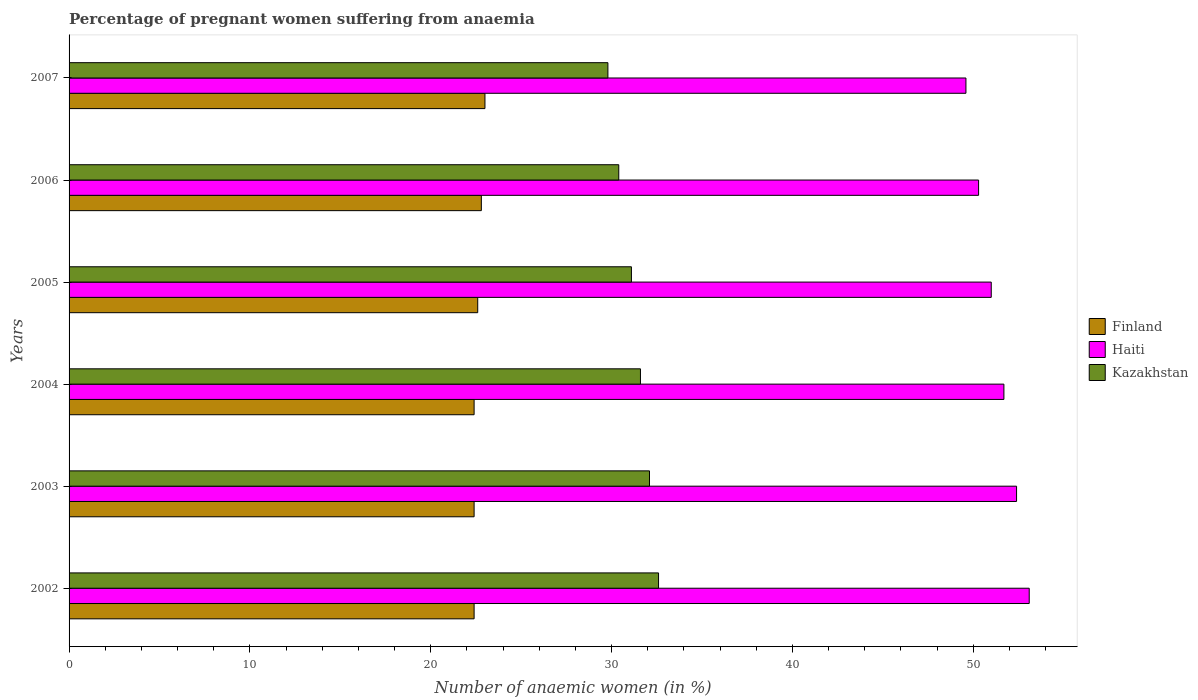How many groups of bars are there?
Offer a very short reply. 6. Are the number of bars per tick equal to the number of legend labels?
Provide a short and direct response. Yes. How many bars are there on the 5th tick from the top?
Offer a terse response. 3. In how many cases, is the number of bars for a given year not equal to the number of legend labels?
Your answer should be very brief. 0. What is the number of anaemic women in Haiti in 2004?
Keep it short and to the point. 51.7. Across all years, what is the maximum number of anaemic women in Haiti?
Your answer should be compact. 53.1. Across all years, what is the minimum number of anaemic women in Kazakhstan?
Your response must be concise. 29.8. In which year was the number of anaemic women in Kazakhstan minimum?
Give a very brief answer. 2007. What is the total number of anaemic women in Haiti in the graph?
Provide a short and direct response. 308.1. What is the difference between the number of anaemic women in Haiti in 2004 and that in 2006?
Make the answer very short. 1.4. What is the difference between the number of anaemic women in Finland in 2006 and the number of anaemic women in Kazakhstan in 2005?
Give a very brief answer. -8.3. What is the average number of anaemic women in Finland per year?
Provide a succinct answer. 22.6. In the year 2006, what is the difference between the number of anaemic women in Finland and number of anaemic women in Haiti?
Your response must be concise. -27.5. What is the ratio of the number of anaemic women in Kazakhstan in 2003 to that in 2007?
Offer a terse response. 1.08. What is the difference between the highest and the second highest number of anaemic women in Haiti?
Provide a succinct answer. 0.7. What is the difference between the highest and the lowest number of anaemic women in Kazakhstan?
Make the answer very short. 2.8. What does the 2nd bar from the top in 2002 represents?
Offer a terse response. Haiti. What does the 3rd bar from the bottom in 2007 represents?
Make the answer very short. Kazakhstan. Is it the case that in every year, the sum of the number of anaemic women in Kazakhstan and number of anaemic women in Haiti is greater than the number of anaemic women in Finland?
Keep it short and to the point. Yes. How many bars are there?
Ensure brevity in your answer.  18. Are the values on the major ticks of X-axis written in scientific E-notation?
Keep it short and to the point. No. Does the graph contain any zero values?
Your response must be concise. No. What is the title of the graph?
Your response must be concise. Percentage of pregnant women suffering from anaemia. Does "San Marino" appear as one of the legend labels in the graph?
Offer a very short reply. No. What is the label or title of the X-axis?
Your answer should be compact. Number of anaemic women (in %). What is the Number of anaemic women (in %) of Finland in 2002?
Make the answer very short. 22.4. What is the Number of anaemic women (in %) of Haiti in 2002?
Your answer should be compact. 53.1. What is the Number of anaemic women (in %) in Kazakhstan in 2002?
Provide a short and direct response. 32.6. What is the Number of anaemic women (in %) in Finland in 2003?
Your answer should be compact. 22.4. What is the Number of anaemic women (in %) in Haiti in 2003?
Your answer should be very brief. 52.4. What is the Number of anaemic women (in %) of Kazakhstan in 2003?
Provide a succinct answer. 32.1. What is the Number of anaemic women (in %) in Finland in 2004?
Ensure brevity in your answer.  22.4. What is the Number of anaemic women (in %) of Haiti in 2004?
Your response must be concise. 51.7. What is the Number of anaemic women (in %) in Kazakhstan in 2004?
Offer a very short reply. 31.6. What is the Number of anaemic women (in %) in Finland in 2005?
Provide a succinct answer. 22.6. What is the Number of anaemic women (in %) of Haiti in 2005?
Provide a short and direct response. 51. What is the Number of anaemic women (in %) in Kazakhstan in 2005?
Your response must be concise. 31.1. What is the Number of anaemic women (in %) of Finland in 2006?
Offer a very short reply. 22.8. What is the Number of anaemic women (in %) of Haiti in 2006?
Make the answer very short. 50.3. What is the Number of anaemic women (in %) of Kazakhstan in 2006?
Your answer should be very brief. 30.4. What is the Number of anaemic women (in %) of Haiti in 2007?
Provide a short and direct response. 49.6. What is the Number of anaemic women (in %) in Kazakhstan in 2007?
Your response must be concise. 29.8. Across all years, what is the maximum Number of anaemic women (in %) in Haiti?
Your answer should be compact. 53.1. Across all years, what is the maximum Number of anaemic women (in %) in Kazakhstan?
Your answer should be very brief. 32.6. Across all years, what is the minimum Number of anaemic women (in %) of Finland?
Provide a short and direct response. 22.4. Across all years, what is the minimum Number of anaemic women (in %) in Haiti?
Provide a short and direct response. 49.6. Across all years, what is the minimum Number of anaemic women (in %) in Kazakhstan?
Provide a short and direct response. 29.8. What is the total Number of anaemic women (in %) of Finland in the graph?
Offer a terse response. 135.6. What is the total Number of anaemic women (in %) in Haiti in the graph?
Your answer should be very brief. 308.1. What is the total Number of anaemic women (in %) in Kazakhstan in the graph?
Provide a succinct answer. 187.6. What is the difference between the Number of anaemic women (in %) of Kazakhstan in 2002 and that in 2003?
Offer a very short reply. 0.5. What is the difference between the Number of anaemic women (in %) of Kazakhstan in 2002 and that in 2004?
Provide a succinct answer. 1. What is the difference between the Number of anaemic women (in %) of Haiti in 2002 and that in 2005?
Keep it short and to the point. 2.1. What is the difference between the Number of anaemic women (in %) in Haiti in 2002 and that in 2006?
Your response must be concise. 2.8. What is the difference between the Number of anaemic women (in %) of Finland in 2002 and that in 2007?
Offer a very short reply. -0.6. What is the difference between the Number of anaemic women (in %) of Kazakhstan in 2002 and that in 2007?
Keep it short and to the point. 2.8. What is the difference between the Number of anaemic women (in %) of Finland in 2003 and that in 2004?
Keep it short and to the point. 0. What is the difference between the Number of anaemic women (in %) of Haiti in 2003 and that in 2004?
Offer a terse response. 0.7. What is the difference between the Number of anaemic women (in %) of Kazakhstan in 2003 and that in 2004?
Ensure brevity in your answer.  0.5. What is the difference between the Number of anaemic women (in %) in Finland in 2003 and that in 2005?
Offer a very short reply. -0.2. What is the difference between the Number of anaemic women (in %) of Haiti in 2003 and that in 2005?
Keep it short and to the point. 1.4. What is the difference between the Number of anaemic women (in %) in Kazakhstan in 2003 and that in 2005?
Your answer should be very brief. 1. What is the difference between the Number of anaemic women (in %) of Haiti in 2003 and that in 2006?
Your answer should be very brief. 2.1. What is the difference between the Number of anaemic women (in %) in Haiti in 2003 and that in 2007?
Make the answer very short. 2.8. What is the difference between the Number of anaemic women (in %) in Kazakhstan in 2003 and that in 2007?
Give a very brief answer. 2.3. What is the difference between the Number of anaemic women (in %) in Haiti in 2004 and that in 2005?
Make the answer very short. 0.7. What is the difference between the Number of anaemic women (in %) of Kazakhstan in 2004 and that in 2006?
Provide a succinct answer. 1.2. What is the difference between the Number of anaemic women (in %) of Finland in 2004 and that in 2007?
Provide a succinct answer. -0.6. What is the difference between the Number of anaemic women (in %) of Haiti in 2004 and that in 2007?
Make the answer very short. 2.1. What is the difference between the Number of anaemic women (in %) in Finland in 2005 and that in 2006?
Provide a short and direct response. -0.2. What is the difference between the Number of anaemic women (in %) of Haiti in 2005 and that in 2006?
Your answer should be compact. 0.7. What is the difference between the Number of anaemic women (in %) in Finland in 2005 and that in 2007?
Offer a very short reply. -0.4. What is the difference between the Number of anaemic women (in %) of Haiti in 2005 and that in 2007?
Your answer should be very brief. 1.4. What is the difference between the Number of anaemic women (in %) in Kazakhstan in 2005 and that in 2007?
Provide a short and direct response. 1.3. What is the difference between the Number of anaemic women (in %) of Kazakhstan in 2006 and that in 2007?
Keep it short and to the point. 0.6. What is the difference between the Number of anaemic women (in %) in Finland in 2002 and the Number of anaemic women (in %) in Haiti in 2004?
Your response must be concise. -29.3. What is the difference between the Number of anaemic women (in %) in Haiti in 2002 and the Number of anaemic women (in %) in Kazakhstan in 2004?
Keep it short and to the point. 21.5. What is the difference between the Number of anaemic women (in %) in Finland in 2002 and the Number of anaemic women (in %) in Haiti in 2005?
Make the answer very short. -28.6. What is the difference between the Number of anaemic women (in %) in Haiti in 2002 and the Number of anaemic women (in %) in Kazakhstan in 2005?
Offer a terse response. 22. What is the difference between the Number of anaemic women (in %) of Finland in 2002 and the Number of anaemic women (in %) of Haiti in 2006?
Your answer should be very brief. -27.9. What is the difference between the Number of anaemic women (in %) in Finland in 2002 and the Number of anaemic women (in %) in Kazakhstan in 2006?
Make the answer very short. -8. What is the difference between the Number of anaemic women (in %) in Haiti in 2002 and the Number of anaemic women (in %) in Kazakhstan in 2006?
Make the answer very short. 22.7. What is the difference between the Number of anaemic women (in %) in Finland in 2002 and the Number of anaemic women (in %) in Haiti in 2007?
Give a very brief answer. -27.2. What is the difference between the Number of anaemic women (in %) in Finland in 2002 and the Number of anaemic women (in %) in Kazakhstan in 2007?
Your response must be concise. -7.4. What is the difference between the Number of anaemic women (in %) in Haiti in 2002 and the Number of anaemic women (in %) in Kazakhstan in 2007?
Keep it short and to the point. 23.3. What is the difference between the Number of anaemic women (in %) of Finland in 2003 and the Number of anaemic women (in %) of Haiti in 2004?
Your answer should be compact. -29.3. What is the difference between the Number of anaemic women (in %) in Haiti in 2003 and the Number of anaemic women (in %) in Kazakhstan in 2004?
Keep it short and to the point. 20.8. What is the difference between the Number of anaemic women (in %) in Finland in 2003 and the Number of anaemic women (in %) in Haiti in 2005?
Offer a terse response. -28.6. What is the difference between the Number of anaemic women (in %) of Haiti in 2003 and the Number of anaemic women (in %) of Kazakhstan in 2005?
Provide a short and direct response. 21.3. What is the difference between the Number of anaemic women (in %) of Finland in 2003 and the Number of anaemic women (in %) of Haiti in 2006?
Give a very brief answer. -27.9. What is the difference between the Number of anaemic women (in %) in Finland in 2003 and the Number of anaemic women (in %) in Haiti in 2007?
Keep it short and to the point. -27.2. What is the difference between the Number of anaemic women (in %) of Finland in 2003 and the Number of anaemic women (in %) of Kazakhstan in 2007?
Your answer should be compact. -7.4. What is the difference between the Number of anaemic women (in %) of Haiti in 2003 and the Number of anaemic women (in %) of Kazakhstan in 2007?
Provide a short and direct response. 22.6. What is the difference between the Number of anaemic women (in %) in Finland in 2004 and the Number of anaemic women (in %) in Haiti in 2005?
Make the answer very short. -28.6. What is the difference between the Number of anaemic women (in %) in Haiti in 2004 and the Number of anaemic women (in %) in Kazakhstan in 2005?
Your response must be concise. 20.6. What is the difference between the Number of anaemic women (in %) of Finland in 2004 and the Number of anaemic women (in %) of Haiti in 2006?
Your answer should be compact. -27.9. What is the difference between the Number of anaemic women (in %) of Finland in 2004 and the Number of anaemic women (in %) of Kazakhstan in 2006?
Offer a terse response. -8. What is the difference between the Number of anaemic women (in %) of Haiti in 2004 and the Number of anaemic women (in %) of Kazakhstan in 2006?
Keep it short and to the point. 21.3. What is the difference between the Number of anaemic women (in %) of Finland in 2004 and the Number of anaemic women (in %) of Haiti in 2007?
Your response must be concise. -27.2. What is the difference between the Number of anaemic women (in %) of Haiti in 2004 and the Number of anaemic women (in %) of Kazakhstan in 2007?
Your answer should be compact. 21.9. What is the difference between the Number of anaemic women (in %) in Finland in 2005 and the Number of anaemic women (in %) in Haiti in 2006?
Ensure brevity in your answer.  -27.7. What is the difference between the Number of anaemic women (in %) of Finland in 2005 and the Number of anaemic women (in %) of Kazakhstan in 2006?
Give a very brief answer. -7.8. What is the difference between the Number of anaemic women (in %) of Haiti in 2005 and the Number of anaemic women (in %) of Kazakhstan in 2006?
Provide a succinct answer. 20.6. What is the difference between the Number of anaemic women (in %) in Haiti in 2005 and the Number of anaemic women (in %) in Kazakhstan in 2007?
Your answer should be compact. 21.2. What is the difference between the Number of anaemic women (in %) in Finland in 2006 and the Number of anaemic women (in %) in Haiti in 2007?
Provide a short and direct response. -26.8. What is the average Number of anaemic women (in %) in Finland per year?
Provide a short and direct response. 22.6. What is the average Number of anaemic women (in %) in Haiti per year?
Your answer should be very brief. 51.35. What is the average Number of anaemic women (in %) in Kazakhstan per year?
Provide a short and direct response. 31.27. In the year 2002, what is the difference between the Number of anaemic women (in %) in Finland and Number of anaemic women (in %) in Haiti?
Your answer should be very brief. -30.7. In the year 2003, what is the difference between the Number of anaemic women (in %) of Finland and Number of anaemic women (in %) of Haiti?
Give a very brief answer. -30. In the year 2003, what is the difference between the Number of anaemic women (in %) of Finland and Number of anaemic women (in %) of Kazakhstan?
Your answer should be compact. -9.7. In the year 2003, what is the difference between the Number of anaemic women (in %) of Haiti and Number of anaemic women (in %) of Kazakhstan?
Give a very brief answer. 20.3. In the year 2004, what is the difference between the Number of anaemic women (in %) in Finland and Number of anaemic women (in %) in Haiti?
Provide a succinct answer. -29.3. In the year 2004, what is the difference between the Number of anaemic women (in %) of Finland and Number of anaemic women (in %) of Kazakhstan?
Make the answer very short. -9.2. In the year 2004, what is the difference between the Number of anaemic women (in %) of Haiti and Number of anaemic women (in %) of Kazakhstan?
Provide a short and direct response. 20.1. In the year 2005, what is the difference between the Number of anaemic women (in %) in Finland and Number of anaemic women (in %) in Haiti?
Make the answer very short. -28.4. In the year 2006, what is the difference between the Number of anaemic women (in %) in Finland and Number of anaemic women (in %) in Haiti?
Give a very brief answer. -27.5. In the year 2006, what is the difference between the Number of anaemic women (in %) in Finland and Number of anaemic women (in %) in Kazakhstan?
Offer a very short reply. -7.6. In the year 2007, what is the difference between the Number of anaemic women (in %) of Finland and Number of anaemic women (in %) of Haiti?
Provide a succinct answer. -26.6. In the year 2007, what is the difference between the Number of anaemic women (in %) of Finland and Number of anaemic women (in %) of Kazakhstan?
Provide a succinct answer. -6.8. In the year 2007, what is the difference between the Number of anaemic women (in %) of Haiti and Number of anaemic women (in %) of Kazakhstan?
Offer a terse response. 19.8. What is the ratio of the Number of anaemic women (in %) of Haiti in 2002 to that in 2003?
Give a very brief answer. 1.01. What is the ratio of the Number of anaemic women (in %) in Kazakhstan in 2002 to that in 2003?
Offer a terse response. 1.02. What is the ratio of the Number of anaemic women (in %) of Finland in 2002 to that in 2004?
Provide a succinct answer. 1. What is the ratio of the Number of anaemic women (in %) of Haiti in 2002 to that in 2004?
Your answer should be very brief. 1.03. What is the ratio of the Number of anaemic women (in %) in Kazakhstan in 2002 to that in 2004?
Your response must be concise. 1.03. What is the ratio of the Number of anaemic women (in %) of Finland in 2002 to that in 2005?
Provide a succinct answer. 0.99. What is the ratio of the Number of anaemic women (in %) of Haiti in 2002 to that in 2005?
Make the answer very short. 1.04. What is the ratio of the Number of anaemic women (in %) of Kazakhstan in 2002 to that in 2005?
Your response must be concise. 1.05. What is the ratio of the Number of anaemic women (in %) of Finland in 2002 to that in 2006?
Make the answer very short. 0.98. What is the ratio of the Number of anaemic women (in %) in Haiti in 2002 to that in 2006?
Offer a terse response. 1.06. What is the ratio of the Number of anaemic women (in %) in Kazakhstan in 2002 to that in 2006?
Your answer should be compact. 1.07. What is the ratio of the Number of anaemic women (in %) in Finland in 2002 to that in 2007?
Offer a very short reply. 0.97. What is the ratio of the Number of anaemic women (in %) of Haiti in 2002 to that in 2007?
Your answer should be very brief. 1.07. What is the ratio of the Number of anaemic women (in %) of Kazakhstan in 2002 to that in 2007?
Give a very brief answer. 1.09. What is the ratio of the Number of anaemic women (in %) of Finland in 2003 to that in 2004?
Offer a terse response. 1. What is the ratio of the Number of anaemic women (in %) of Haiti in 2003 to that in 2004?
Give a very brief answer. 1.01. What is the ratio of the Number of anaemic women (in %) of Kazakhstan in 2003 to that in 2004?
Provide a short and direct response. 1.02. What is the ratio of the Number of anaemic women (in %) in Haiti in 2003 to that in 2005?
Make the answer very short. 1.03. What is the ratio of the Number of anaemic women (in %) in Kazakhstan in 2003 to that in 2005?
Offer a terse response. 1.03. What is the ratio of the Number of anaemic women (in %) of Finland in 2003 to that in 2006?
Make the answer very short. 0.98. What is the ratio of the Number of anaemic women (in %) in Haiti in 2003 to that in 2006?
Offer a terse response. 1.04. What is the ratio of the Number of anaemic women (in %) in Kazakhstan in 2003 to that in 2006?
Offer a very short reply. 1.06. What is the ratio of the Number of anaemic women (in %) of Finland in 2003 to that in 2007?
Ensure brevity in your answer.  0.97. What is the ratio of the Number of anaemic women (in %) in Haiti in 2003 to that in 2007?
Offer a terse response. 1.06. What is the ratio of the Number of anaemic women (in %) in Kazakhstan in 2003 to that in 2007?
Your response must be concise. 1.08. What is the ratio of the Number of anaemic women (in %) in Finland in 2004 to that in 2005?
Offer a terse response. 0.99. What is the ratio of the Number of anaemic women (in %) of Haiti in 2004 to that in 2005?
Your answer should be compact. 1.01. What is the ratio of the Number of anaemic women (in %) of Kazakhstan in 2004 to that in 2005?
Keep it short and to the point. 1.02. What is the ratio of the Number of anaemic women (in %) in Finland in 2004 to that in 2006?
Provide a succinct answer. 0.98. What is the ratio of the Number of anaemic women (in %) in Haiti in 2004 to that in 2006?
Provide a short and direct response. 1.03. What is the ratio of the Number of anaemic women (in %) in Kazakhstan in 2004 to that in 2006?
Your answer should be very brief. 1.04. What is the ratio of the Number of anaemic women (in %) in Finland in 2004 to that in 2007?
Your answer should be compact. 0.97. What is the ratio of the Number of anaemic women (in %) of Haiti in 2004 to that in 2007?
Give a very brief answer. 1.04. What is the ratio of the Number of anaemic women (in %) in Kazakhstan in 2004 to that in 2007?
Make the answer very short. 1.06. What is the ratio of the Number of anaemic women (in %) of Haiti in 2005 to that in 2006?
Your answer should be compact. 1.01. What is the ratio of the Number of anaemic women (in %) in Kazakhstan in 2005 to that in 2006?
Give a very brief answer. 1.02. What is the ratio of the Number of anaemic women (in %) in Finland in 2005 to that in 2007?
Make the answer very short. 0.98. What is the ratio of the Number of anaemic women (in %) in Haiti in 2005 to that in 2007?
Give a very brief answer. 1.03. What is the ratio of the Number of anaemic women (in %) in Kazakhstan in 2005 to that in 2007?
Your answer should be compact. 1.04. What is the ratio of the Number of anaemic women (in %) of Haiti in 2006 to that in 2007?
Ensure brevity in your answer.  1.01. What is the ratio of the Number of anaemic women (in %) of Kazakhstan in 2006 to that in 2007?
Your answer should be compact. 1.02. What is the difference between the highest and the second highest Number of anaemic women (in %) in Kazakhstan?
Offer a very short reply. 0.5. 